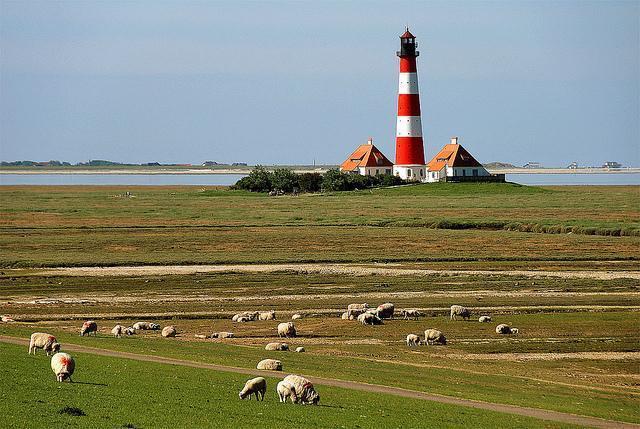How many people are there?
Give a very brief answer. 0. 